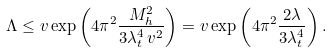<formula> <loc_0><loc_0><loc_500><loc_500>\Lambda \leq v \exp \left ( 4 \pi ^ { 2 } \frac { M ^ { 2 } _ { h } } { 3 \lambda _ { t } ^ { 4 } \, v ^ { 2 } } \right ) = v \exp \left ( 4 \pi ^ { 2 } \frac { 2 \lambda } { 3 \lambda _ { t } ^ { 4 } } \right ) .</formula> 